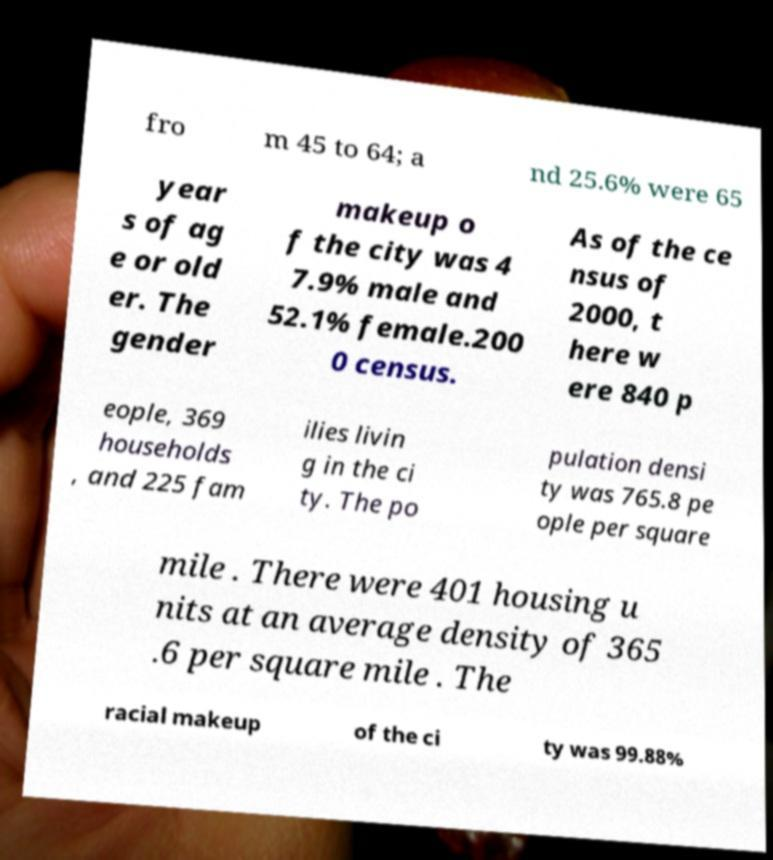Can you read and provide the text displayed in the image?This photo seems to have some interesting text. Can you extract and type it out for me? fro m 45 to 64; a nd 25.6% were 65 year s of ag e or old er. The gender makeup o f the city was 4 7.9% male and 52.1% female.200 0 census. As of the ce nsus of 2000, t here w ere 840 p eople, 369 households , and 225 fam ilies livin g in the ci ty. The po pulation densi ty was 765.8 pe ople per square mile . There were 401 housing u nits at an average density of 365 .6 per square mile . The racial makeup of the ci ty was 99.88% 